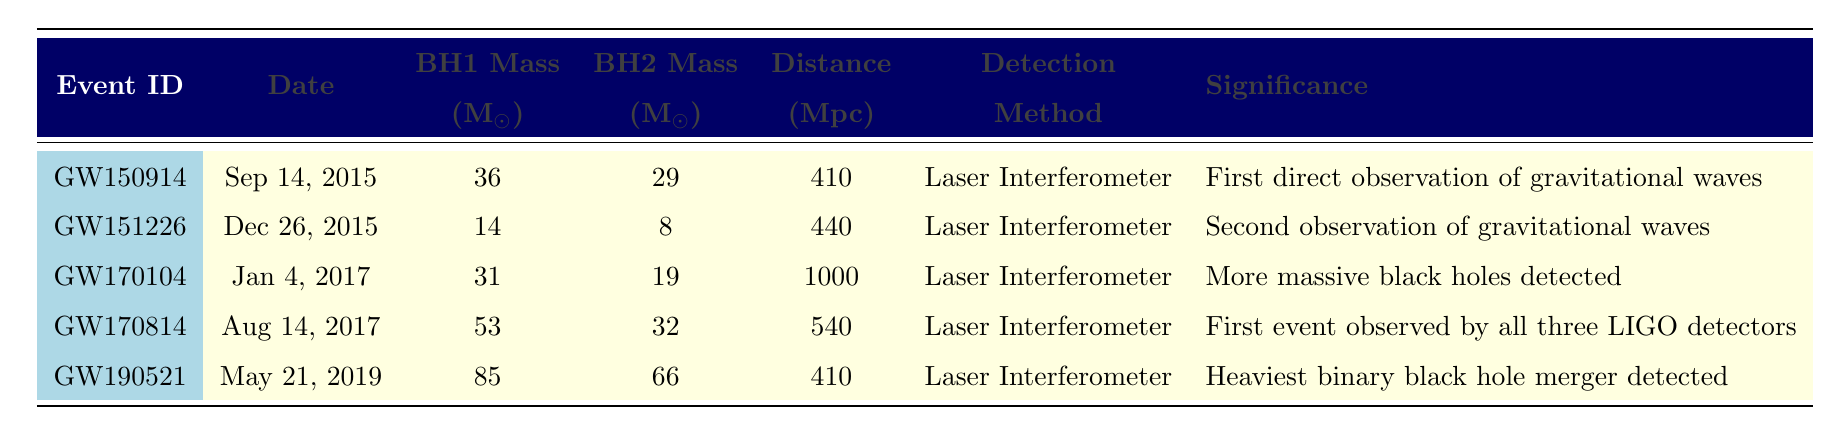What is the date of the first gravitational wave event? The table lists the events chronologically, with the first event being GW150914, which occurred on September 14, 2015.
Answer: September 14, 2015 Which event had the highest combined mass of black holes? To find the event with the highest combined mass, we add the masses of the black holes from each event. GW190521 has a combined mass of 85 + 66 = 151 solar masses, which is the highest among the listed events.
Answer: GW190521 Was the distance of the event GW170104 more than 800 Mpc? The distance for GW170104 is provided as 1000 Mpc. Since 1000 is greater than 800, the answer is yes.
Answer: Yes What are the masses of the black holes in event GW151226? The table specifies the masses for GW151226: Black Hole 1 has a mass of 14 solar masses, and Black Hole 2 has a mass of 8 solar masses.
Answer: 14 and 8 solar masses What is the average distance of all the events listed? The distances to each event are: 410, 440, 1000, 540, and 410 Mpc. Adding them gives a total of 410 + 440 + 1000 + 540 + 410 = 2800 Mpc. Dividing by 5 (the number of events) gives an average of 560 Mpc.
Answer: 560 Mpc Was GW170814 observed with more than two detectors? The significance for GW170814 states that it was the first event observed by all three LIGO detectors, indicating that it was indeed observed with more than two detectors.
Answer: Yes Which event occurred most recently? The event GW190521 is listed as happening on May 21, 2019, which is the most recent date when compared to the other events in the table.
Answer: May 21, 2019 How many solar masses do the black holes in GW150914 total? The table shows the masses for GW150914: 36 solar masses for Black Hole 1 and 29 solar masses for Black Hole 2. Their total mass is 36 + 29 = 65 solar masses.
Answer: 65 solar masses 